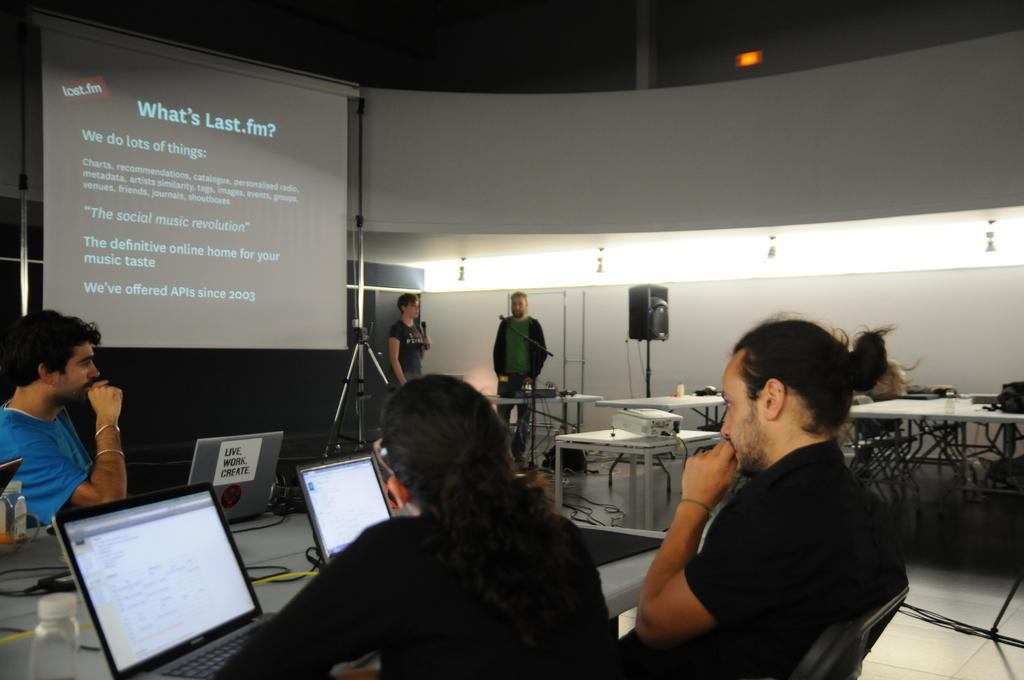<image>
Present a compact description of the photo's key features. People are sitting in front of laptops and learning about Last.fm. 